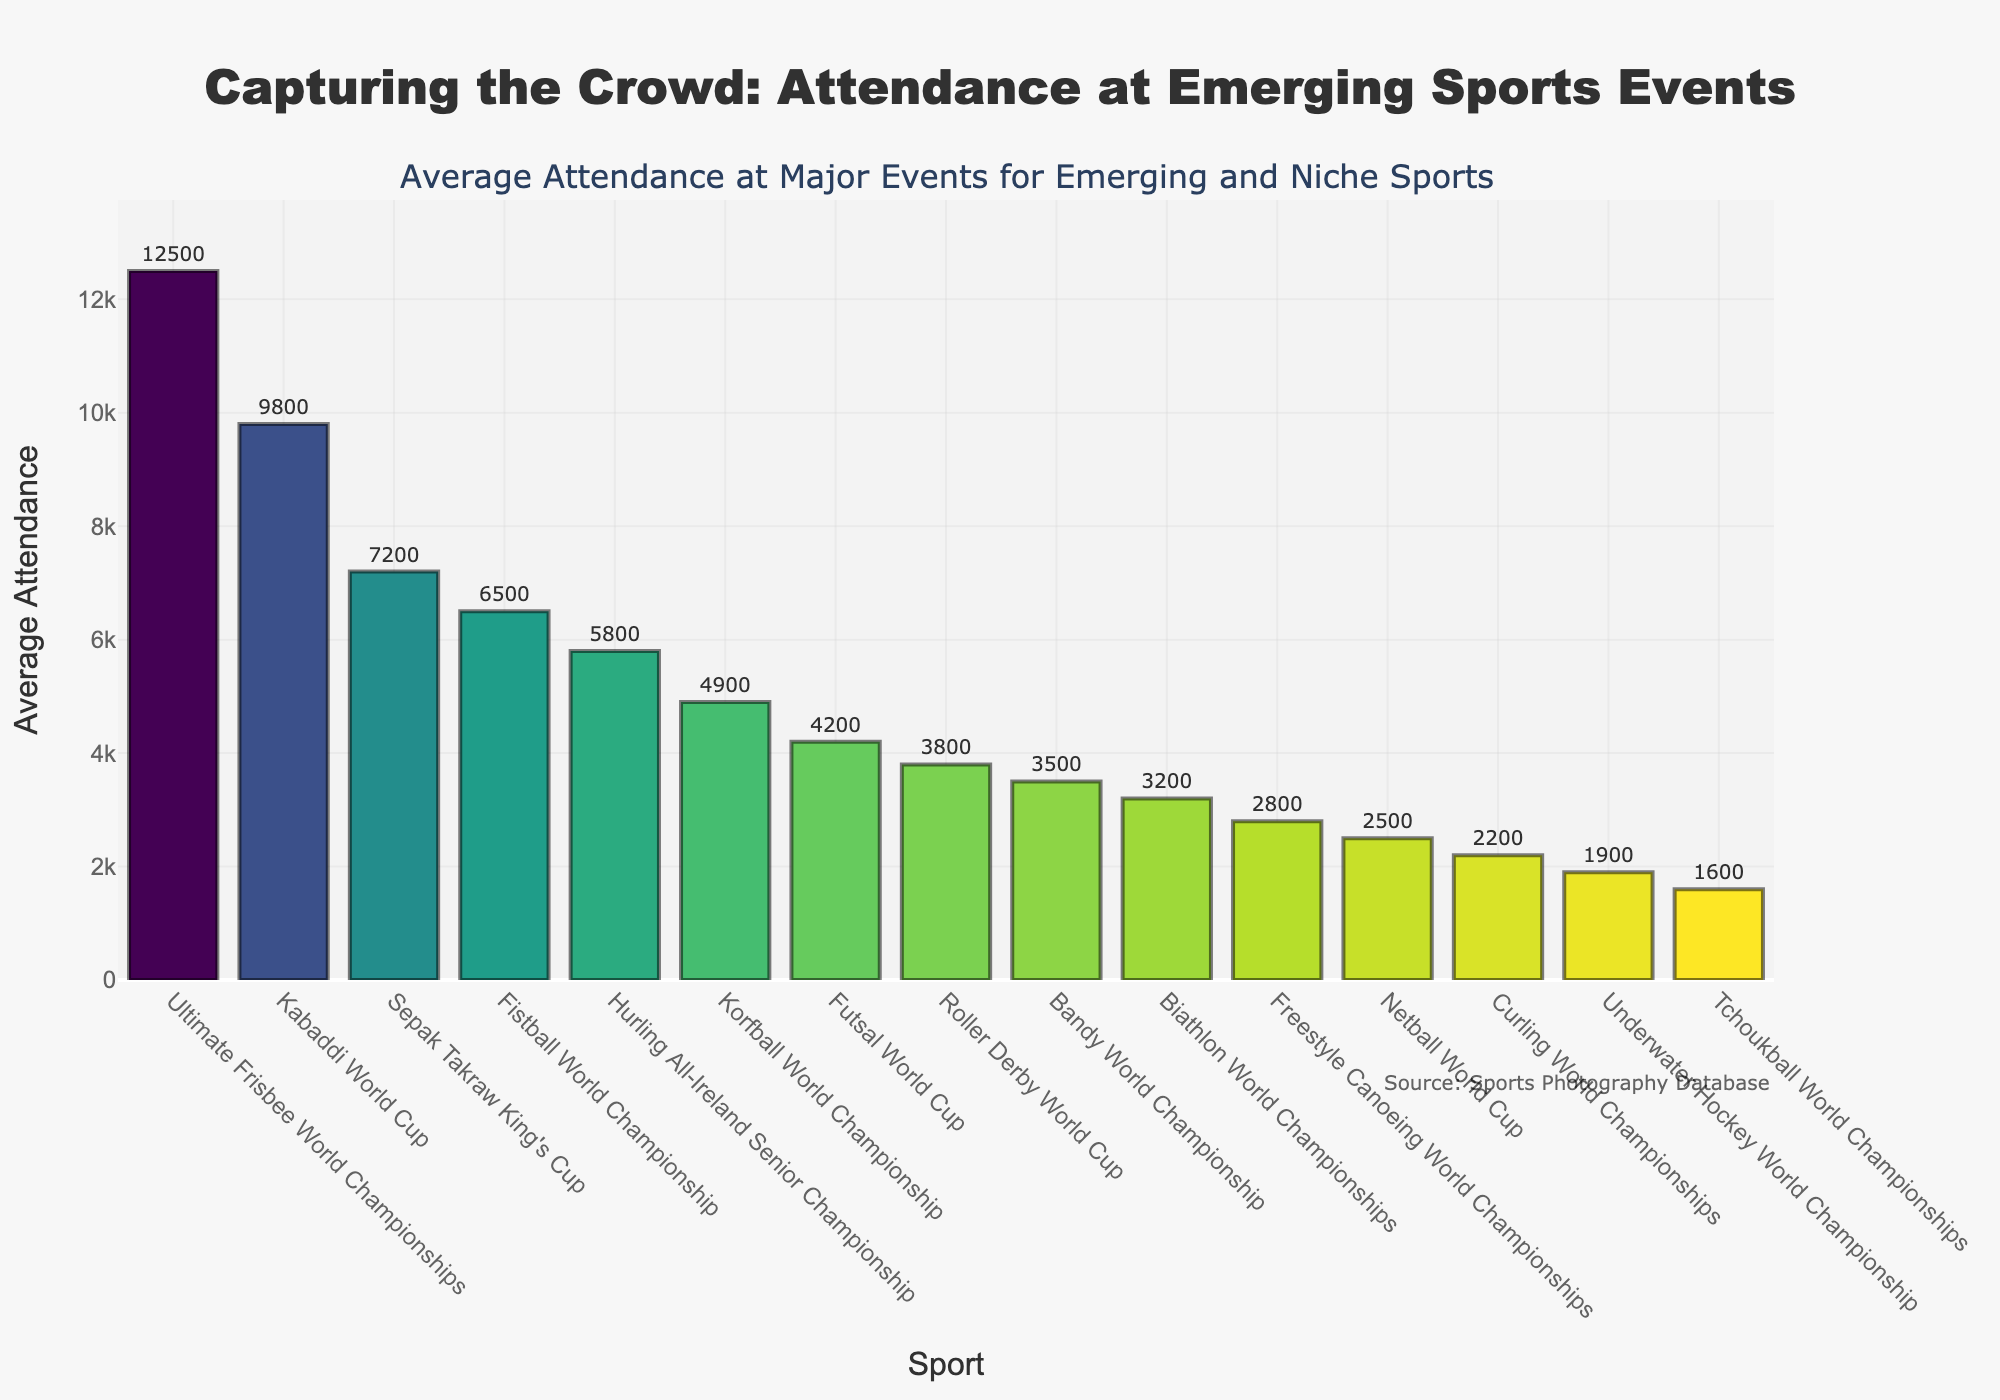Which sport has the highest average attendance according to the figure? The highest bar represents the sport with the highest average attendance. By looking at the bar height, Ultimate Frisbee World Championships has the tallest bar.
Answer: Ultimate Frisbee World Championships Which sport has the lowest average attendance? The shortest bar shows the sport with the lowest average attendance. By examining the bar length, Tchoukball World Championships has the shortest bar.
Answer: Tchoukball World Championships How much higher is the average attendance for Ultimate Frisbee World Championships compared to Netball World Cup? Identify the bars for Ultimate Frisbee World Championships and Netball World Cup and subtract their values. Ultimate Frisbee World Championships: 12500, Netball World Cup: 2500. The difference is 12500 - 2500.
Answer: 10000 What is the average attendance for Bandy World Championship? Find the bar corresponding to Bandy World Championship and read the value. The bar displays an attendance of 3500.
Answer: 3500 Which sport has greater average attendance: Sepak Takraw King's Cup or Roller Derby World Cup? Compare the bars for Sepak Takraw King's Cup (7200) and Roller Derby World Cup (3800). Sepak Takraw King's Cup has a higher value.
Answer: Sepak Takraw King's Cup By how much does the average attendance for Futsal World Cup exceed Curling World Championships? Identify and subtract the values for Futsal World Cup (4200) and Curling World Championships (2200). The difference is 4200 - 2200.
Answer: 2000 Which sport has nearly twice the average attendance of Curling World Championships? Compare Curling World Championships (2200) with other sport’s attendance. Netball World Cup (2500) is closest to twice the value of Curling’s (2200 x 2 ≈ 4400).
Answer: Netball World Cup What’s the combined average attendance for Kabaddi World Cup and Fistball World Championship? Sum the average attendance values of Kabaddi World Cup (9800) and Fistball World Championship (6500). The total is 9800 + 6500.
Answer: 16300 Which sports have an average attendance between 3000 and 6000? Identify bars within the 3000 and 6000 range. Hurling All-Ireland Senior Championship (5800), Korfball World Championship (4900), Futsal World Cup (4200), and Roller Derby World Cup (3800) fall in this range.
Answer: Hurling All-Ireland Senior Championship, Korfball World Championship, Futsal World Cup, Roller Derby World Cup What is the difference in average attendance between the Sepak Takraw King's Cup and the Korfball World Championship? Subtract the value of Korfball World Championship (4900) from the value of Sepak Takraw King's Cup (7200). The difference is 7200 - 4900.
Answer: 2300 